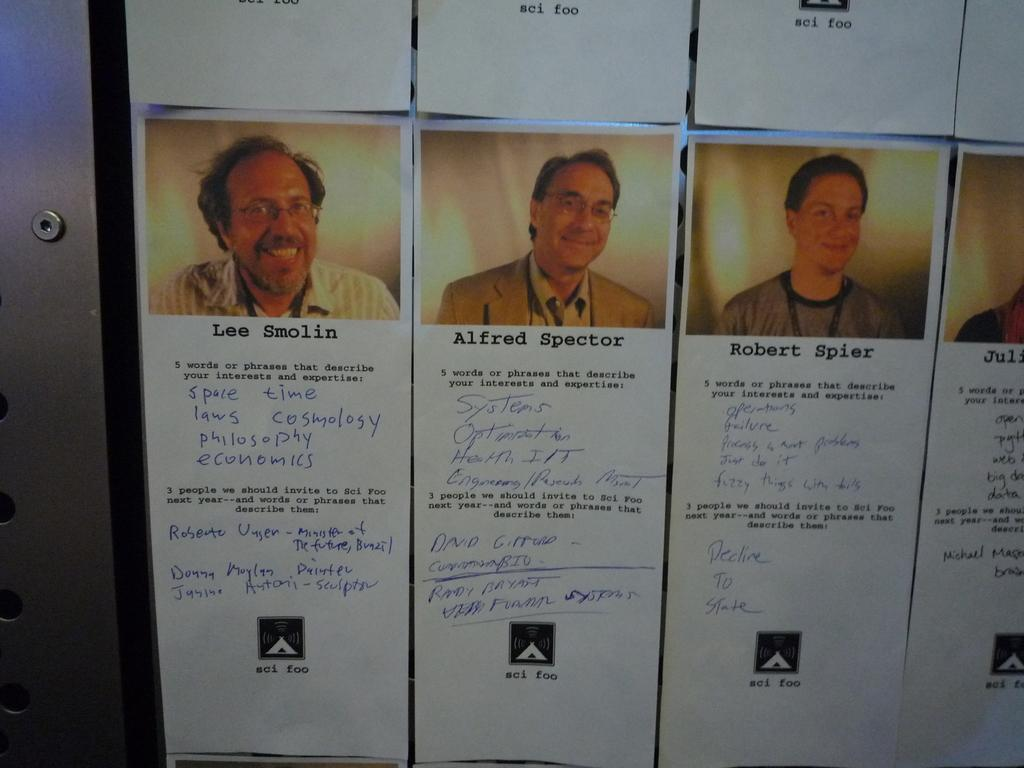What type of images are displayed on the wall in the image? There are photographs of men on the wall. What additional information is provided below the photographs? There is text below the photographs. Can you see a squirrel climbing the wall in the image? No, there is no squirrel present in the image. What type of ship is docked near the wall in the image? There is no ship present in the image; it only features photographs of men on the wall. 